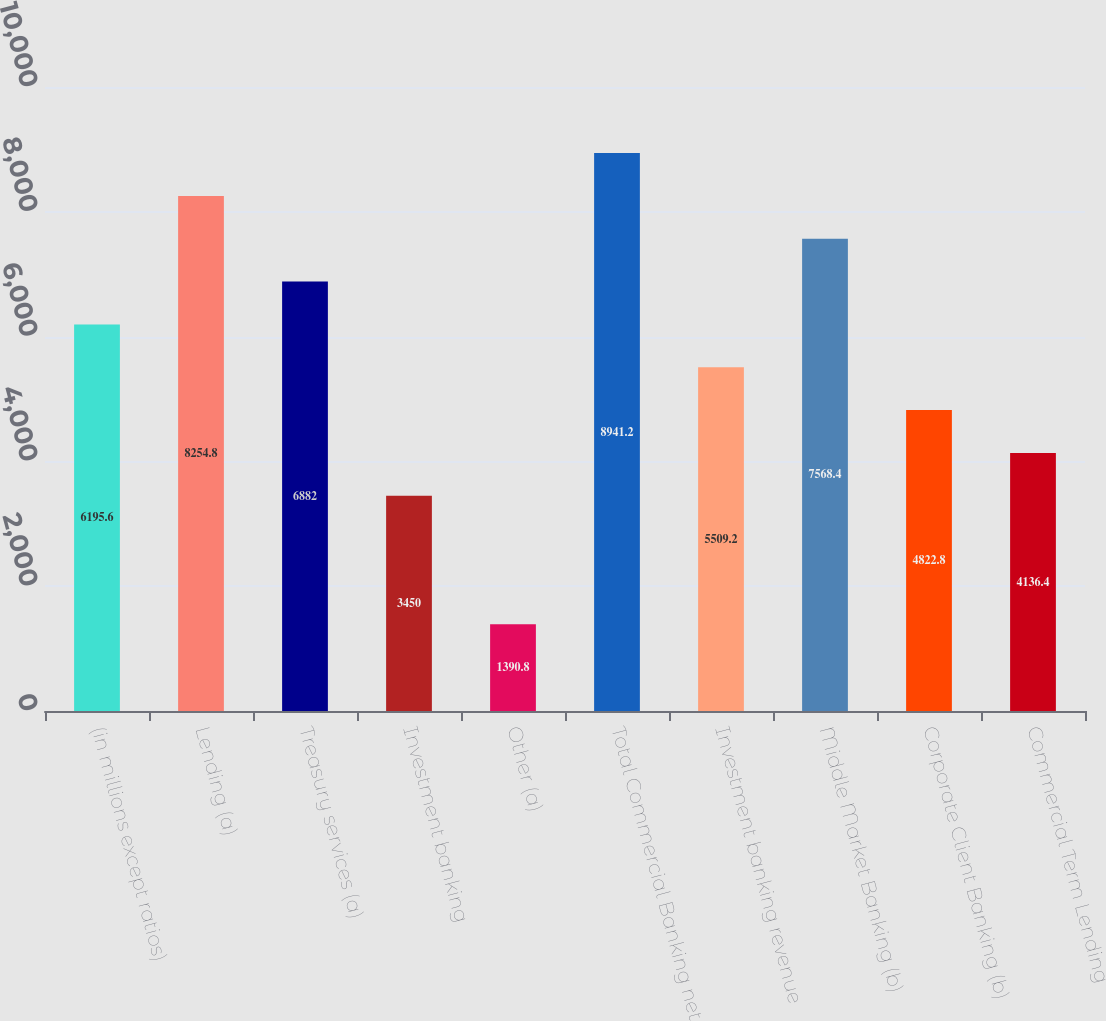Convert chart to OTSL. <chart><loc_0><loc_0><loc_500><loc_500><bar_chart><fcel>(in millions except ratios)<fcel>Lending (a)<fcel>Treasury services (a)<fcel>Investment banking<fcel>Other (a)<fcel>Total Commercial Banking net<fcel>Investment banking revenue<fcel>Middle Market Banking (b)<fcel>Corporate Client Banking (b)<fcel>Commercial Term Lending<nl><fcel>6195.6<fcel>8254.8<fcel>6882<fcel>3450<fcel>1390.8<fcel>8941.2<fcel>5509.2<fcel>7568.4<fcel>4822.8<fcel>4136.4<nl></chart> 